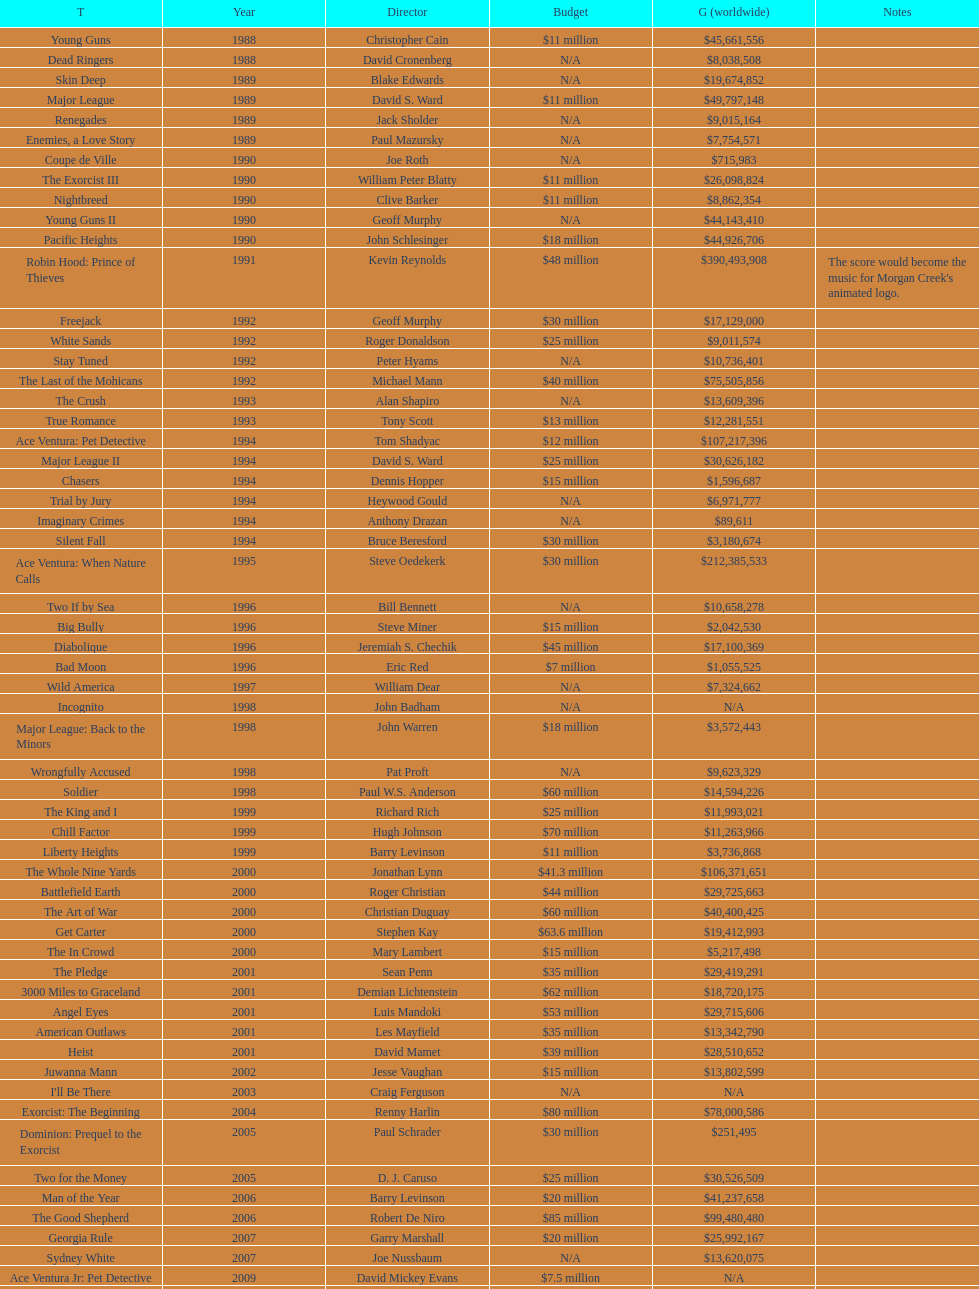I'm looking to parse the entire table for insights. Could you assist me with that? {'header': ['T', 'Year', 'Director', 'Budget', 'G (worldwide)', 'Notes'], 'rows': [['Young Guns', '1988', 'Christopher Cain', '$11 million', '$45,661,556', ''], ['Dead Ringers', '1988', 'David Cronenberg', 'N/A', '$8,038,508', ''], ['Skin Deep', '1989', 'Blake Edwards', 'N/A', '$19,674,852', ''], ['Major League', '1989', 'David S. Ward', '$11 million', '$49,797,148', ''], ['Renegades', '1989', 'Jack Sholder', 'N/A', '$9,015,164', ''], ['Enemies, a Love Story', '1989', 'Paul Mazursky', 'N/A', '$7,754,571', ''], ['Coupe de Ville', '1990', 'Joe Roth', 'N/A', '$715,983', ''], ['The Exorcist III', '1990', 'William Peter Blatty', '$11 million', '$26,098,824', ''], ['Nightbreed', '1990', 'Clive Barker', '$11 million', '$8,862,354', ''], ['Young Guns II', '1990', 'Geoff Murphy', 'N/A', '$44,143,410', ''], ['Pacific Heights', '1990', 'John Schlesinger', '$18 million', '$44,926,706', ''], ['Robin Hood: Prince of Thieves', '1991', 'Kevin Reynolds', '$48 million', '$390,493,908', "The score would become the music for Morgan Creek's animated logo."], ['Freejack', '1992', 'Geoff Murphy', '$30 million', '$17,129,000', ''], ['White Sands', '1992', 'Roger Donaldson', '$25 million', '$9,011,574', ''], ['Stay Tuned', '1992', 'Peter Hyams', 'N/A', '$10,736,401', ''], ['The Last of the Mohicans', '1992', 'Michael Mann', '$40 million', '$75,505,856', ''], ['The Crush', '1993', 'Alan Shapiro', 'N/A', '$13,609,396', ''], ['True Romance', '1993', 'Tony Scott', '$13 million', '$12,281,551', ''], ['Ace Ventura: Pet Detective', '1994', 'Tom Shadyac', '$12 million', '$107,217,396', ''], ['Major League II', '1994', 'David S. Ward', '$25 million', '$30,626,182', ''], ['Chasers', '1994', 'Dennis Hopper', '$15 million', '$1,596,687', ''], ['Trial by Jury', '1994', 'Heywood Gould', 'N/A', '$6,971,777', ''], ['Imaginary Crimes', '1994', 'Anthony Drazan', 'N/A', '$89,611', ''], ['Silent Fall', '1994', 'Bruce Beresford', '$30 million', '$3,180,674', ''], ['Ace Ventura: When Nature Calls', '1995', 'Steve Oedekerk', '$30 million', '$212,385,533', ''], ['Two If by Sea', '1996', 'Bill Bennett', 'N/A', '$10,658,278', ''], ['Big Bully', '1996', 'Steve Miner', '$15 million', '$2,042,530', ''], ['Diabolique', '1996', 'Jeremiah S. Chechik', '$45 million', '$17,100,369', ''], ['Bad Moon', '1996', 'Eric Red', '$7 million', '$1,055,525', ''], ['Wild America', '1997', 'William Dear', 'N/A', '$7,324,662', ''], ['Incognito', '1998', 'John Badham', 'N/A', 'N/A', ''], ['Major League: Back to the Minors', '1998', 'John Warren', '$18 million', '$3,572,443', ''], ['Wrongfully Accused', '1998', 'Pat Proft', 'N/A', '$9,623,329', ''], ['Soldier', '1998', 'Paul W.S. Anderson', '$60 million', '$14,594,226', ''], ['The King and I', '1999', 'Richard Rich', '$25 million', '$11,993,021', ''], ['Chill Factor', '1999', 'Hugh Johnson', '$70 million', '$11,263,966', ''], ['Liberty Heights', '1999', 'Barry Levinson', '$11 million', '$3,736,868', ''], ['The Whole Nine Yards', '2000', 'Jonathan Lynn', '$41.3 million', '$106,371,651', ''], ['Battlefield Earth', '2000', 'Roger Christian', '$44 million', '$29,725,663', ''], ['The Art of War', '2000', 'Christian Duguay', '$60 million', '$40,400,425', ''], ['Get Carter', '2000', 'Stephen Kay', '$63.6 million', '$19,412,993', ''], ['The In Crowd', '2000', 'Mary Lambert', '$15 million', '$5,217,498', ''], ['The Pledge', '2001', 'Sean Penn', '$35 million', '$29,419,291', ''], ['3000 Miles to Graceland', '2001', 'Demian Lichtenstein', '$62 million', '$18,720,175', ''], ['Angel Eyes', '2001', 'Luis Mandoki', '$53 million', '$29,715,606', ''], ['American Outlaws', '2001', 'Les Mayfield', '$35 million', '$13,342,790', ''], ['Heist', '2001', 'David Mamet', '$39 million', '$28,510,652', ''], ['Juwanna Mann', '2002', 'Jesse Vaughan', '$15 million', '$13,802,599', ''], ["I'll Be There", '2003', 'Craig Ferguson', 'N/A', 'N/A', ''], ['Exorcist: The Beginning', '2004', 'Renny Harlin', '$80 million', '$78,000,586', ''], ['Dominion: Prequel to the Exorcist', '2005', 'Paul Schrader', '$30 million', '$251,495', ''], ['Two for the Money', '2005', 'D. J. Caruso', '$25 million', '$30,526,509', ''], ['Man of the Year', '2006', 'Barry Levinson', '$20 million', '$41,237,658', ''], ['The Good Shepherd', '2006', 'Robert De Niro', '$85 million', '$99,480,480', ''], ['Georgia Rule', '2007', 'Garry Marshall', '$20 million', '$25,992,167', ''], ['Sydney White', '2007', 'Joe Nussbaum', 'N/A', '$13,620,075', ''], ['Ace Ventura Jr: Pet Detective', '2009', 'David Mickey Evans', '$7.5 million', 'N/A', ''], ['Dream House', '2011', 'Jim Sheridan', '$50 million', '$38,502,340', ''], ['The Thing', '2011', 'Matthijs van Heijningen Jr.', '$38 million', '$27,428,670', ''], ['Tupac', '2014', 'Antoine Fuqua', '$45 million', '', '']]} What is the number of films directed by david s. ward? 2. 